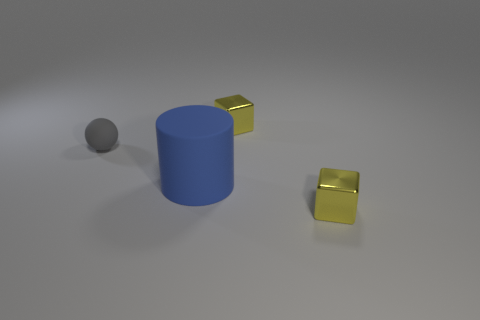Add 4 tiny gray things. How many objects exist? 8 Subtract all gray spheres. How many red cylinders are left? 0 Subtract all tiny yellow blocks. Subtract all large cylinders. How many objects are left? 1 Add 3 blue rubber cylinders. How many blue rubber cylinders are left? 4 Add 2 tiny yellow metallic cubes. How many tiny yellow metallic cubes exist? 4 Subtract 0 green spheres. How many objects are left? 4 Subtract all cylinders. How many objects are left? 3 Subtract 1 balls. How many balls are left? 0 Subtract all brown blocks. Subtract all green cylinders. How many blocks are left? 2 